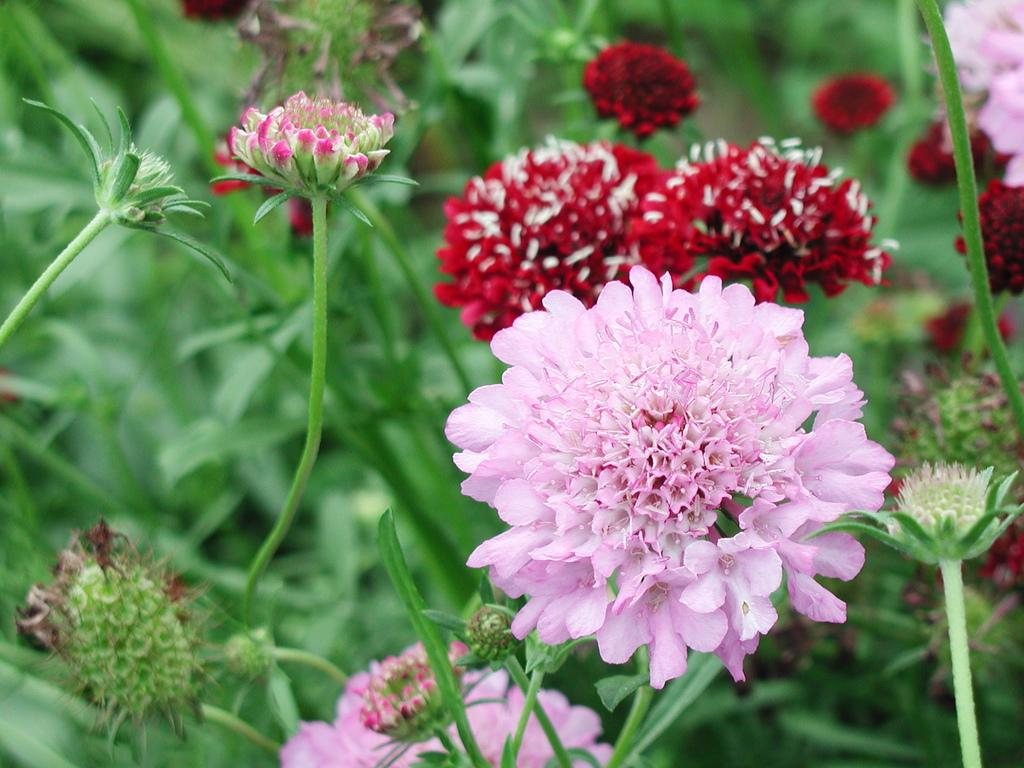What type of living organisms can be seen in the image? There are flowers in the image. What colors are the flowers in the image? The flowers are in pink, white, and red colors. What color are the plants that the flowers are growing on? The plants are in green color. Can you tell me how many boats are visible in the image? There are no boats present in the image; it features flowers and plants. What type of lamp is illuminating the flowers in the image? There is no lamp present in the image; it is focused on the flowers and plants. 